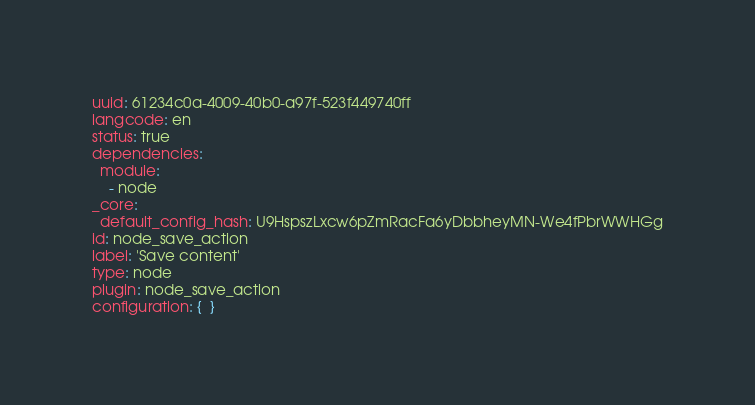<code> <loc_0><loc_0><loc_500><loc_500><_YAML_>uuid: 61234c0a-4009-40b0-a97f-523f449740ff
langcode: en
status: true
dependencies:
  module:
    - node
_core:
  default_config_hash: U9HspszLxcw6pZmRacFa6yDbbheyMN-We4fPbrWWHGg
id: node_save_action
label: 'Save content'
type: node
plugin: node_save_action
configuration: {  }
</code> 